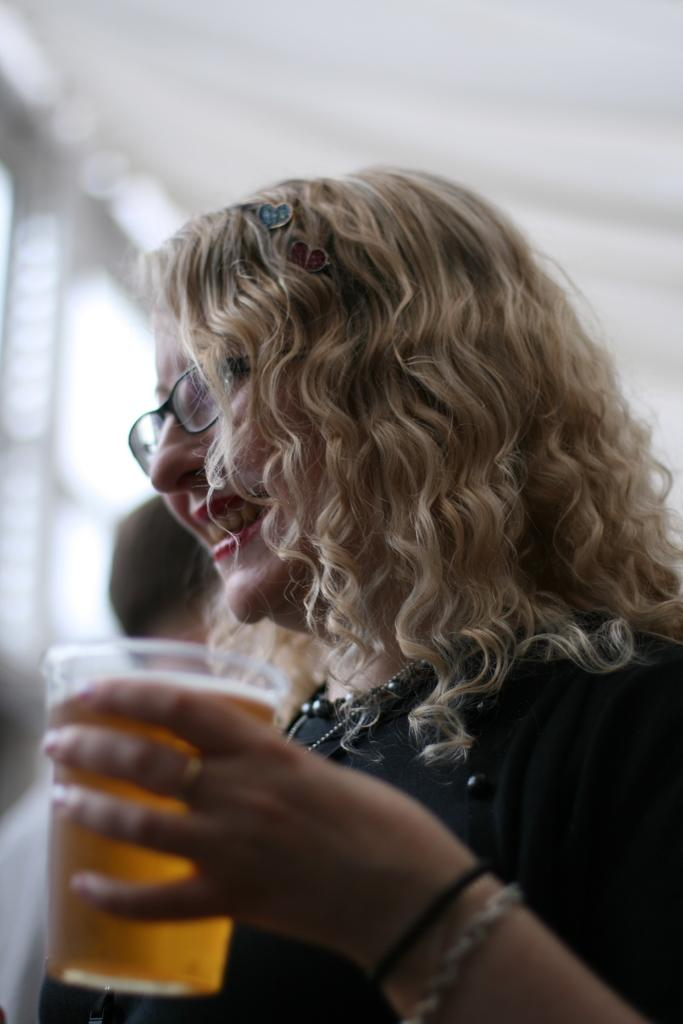Who is the main subject in the image? There is a woman in the image. What is the woman holding in the image? The woman is holding a beer glass. What is the woman's facial expression in the image? The woman is smiling. What color is the top the woman is wearing in the image? The woman is wearing a black color top. What accessory is the woman wearing in the image? The woman is wearing spectacles. How many brothers does the woman have in the image? There is no information about the woman's brothers in the image, so we cannot determine their number. What key is the woman using to open the door in the image? There is no door or key present in the image. 